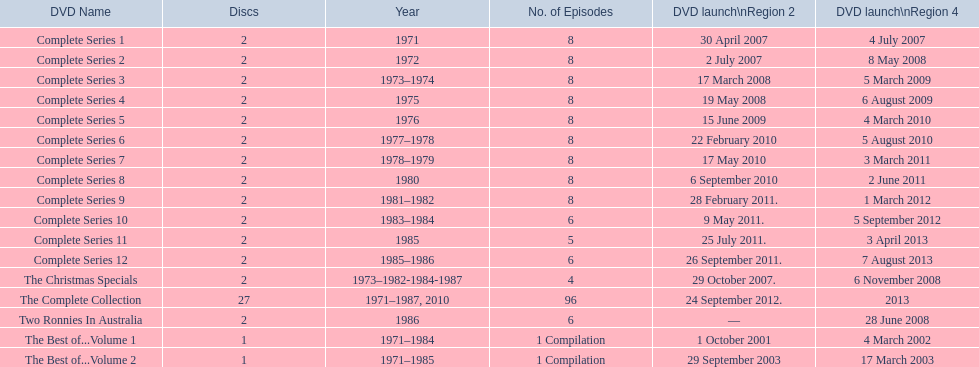True or false. the television show "the two ronnies" featured more than 10 episodes in a season. False. 